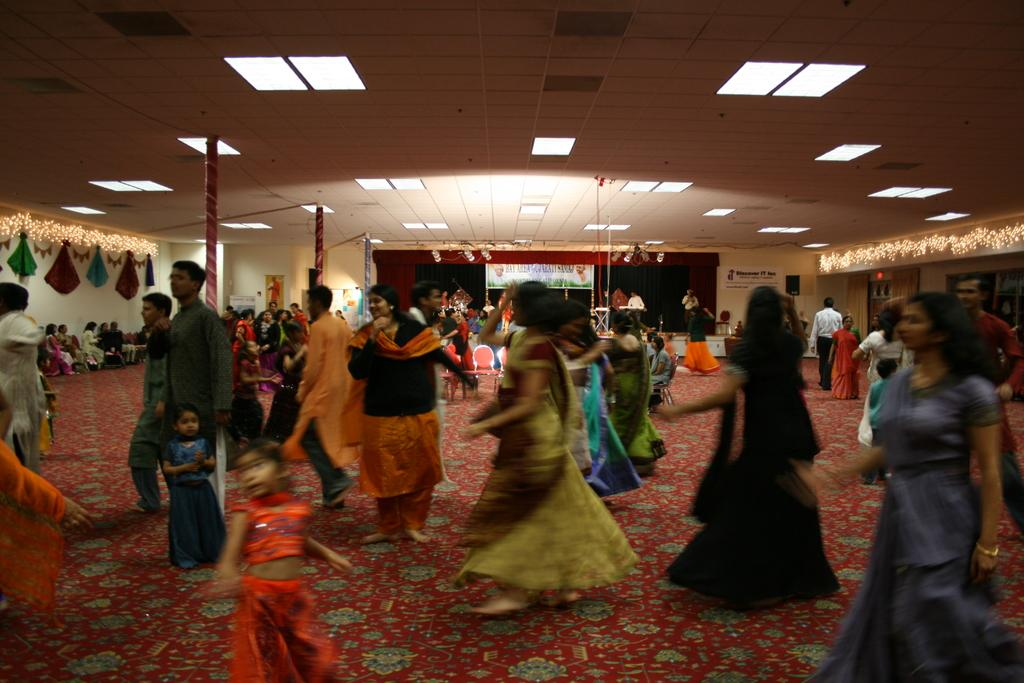What are the people in the image doing? The people in the image are dancing in the center. What can be seen in the background of the image? There is a board and lights visible in the background. What type of window treatment is on the left side of the image? There are curtains on the left side of the image. What is at the bottom of the image? There is a carpet at the bottom of the image. What position does the fireman hold in the image? There is no fireman present in the image. What type of authority is depicted in the image? The image does not depict any authority figures. 